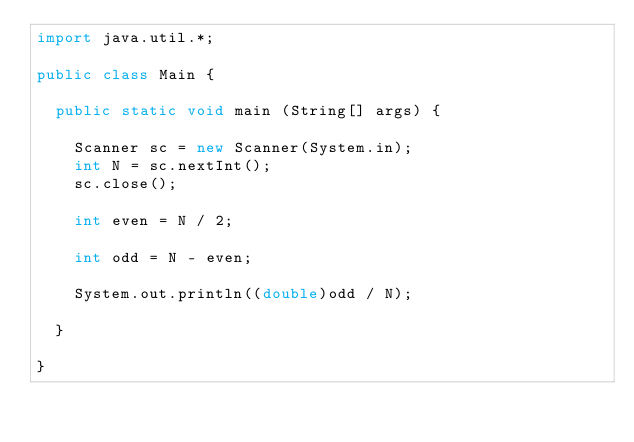<code> <loc_0><loc_0><loc_500><loc_500><_Java_>import java.util.*;

public class Main {

  public static void main (String[] args) {

    Scanner sc = new Scanner(System.in);
    int N = sc.nextInt();
    sc.close();

    int even = N / 2;
  
    int odd = N - even;
    
    System.out.println((double)odd / N);
    
  }

}</code> 